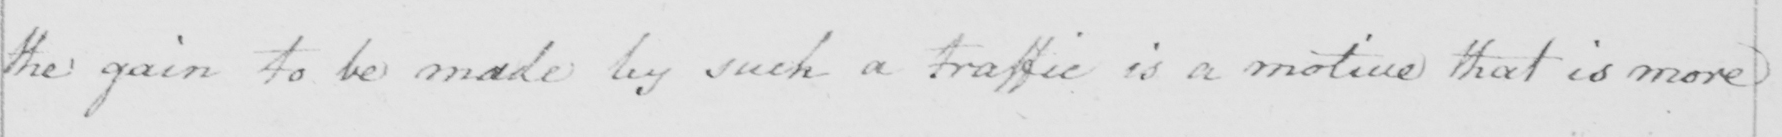Transcribe the text shown in this historical manuscript line. the gain to be made by such a traffic is a motive that is more 